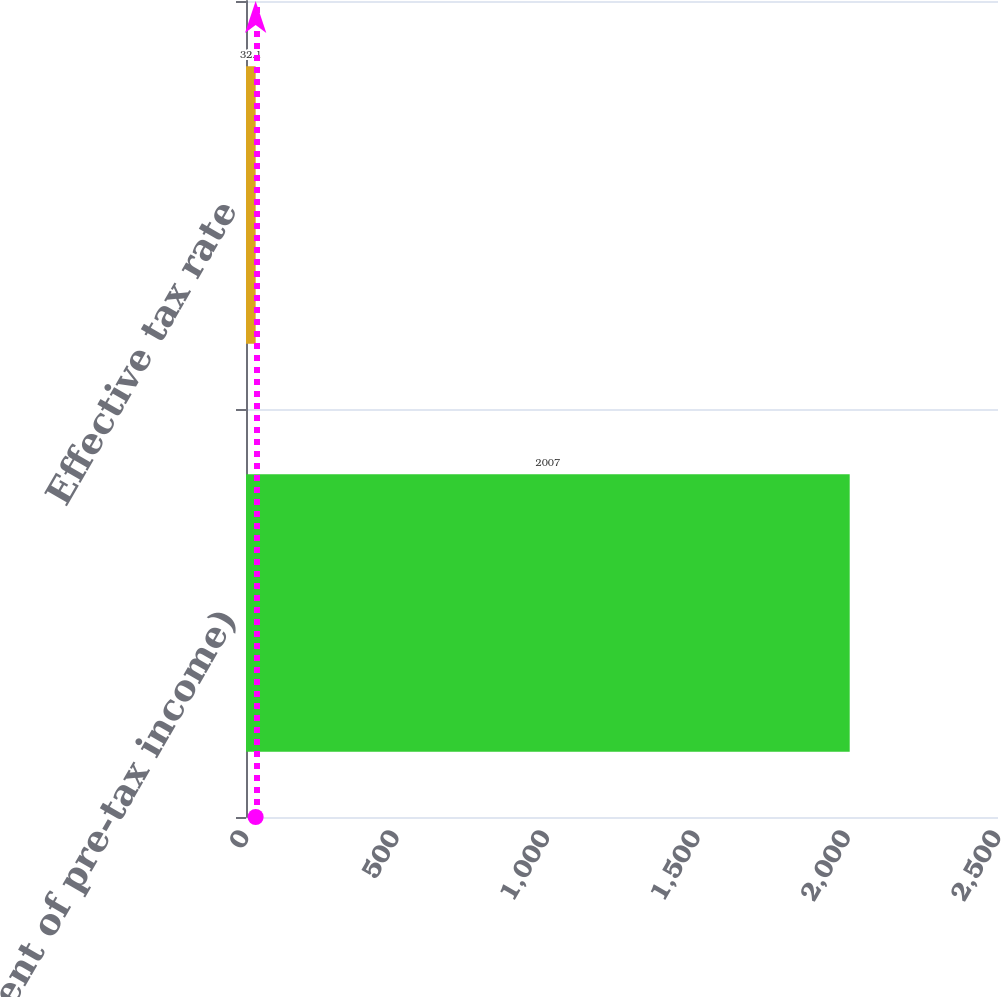Convert chart. <chart><loc_0><loc_0><loc_500><loc_500><bar_chart><fcel>(Percent of pre-tax income)<fcel>Effective tax rate<nl><fcel>2007<fcel>32.1<nl></chart> 